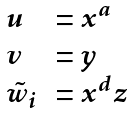Convert formula to latex. <formula><loc_0><loc_0><loc_500><loc_500>\begin{array} { l l } u & = x ^ { a } \\ v & = y \\ \tilde { w } _ { i } & = x ^ { d } z \end{array}</formula> 